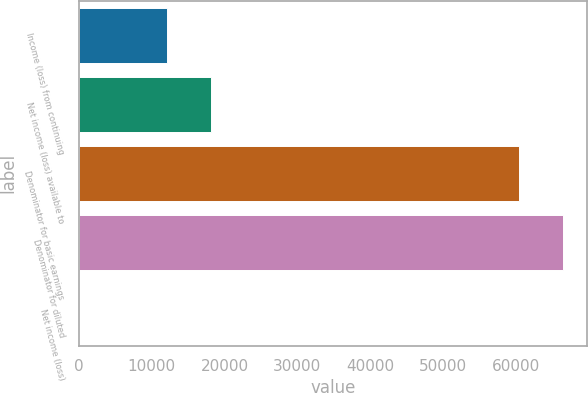<chart> <loc_0><loc_0><loc_500><loc_500><bar_chart><fcel>Income (loss) from continuing<fcel>Net income (loss) available to<fcel>Denominator for basic earnings<fcel>Denominator for diluted<fcel>Net income (loss)<nl><fcel>12091.4<fcel>18136.8<fcel>60455<fcel>66500.5<fcel>0.44<nl></chart> 